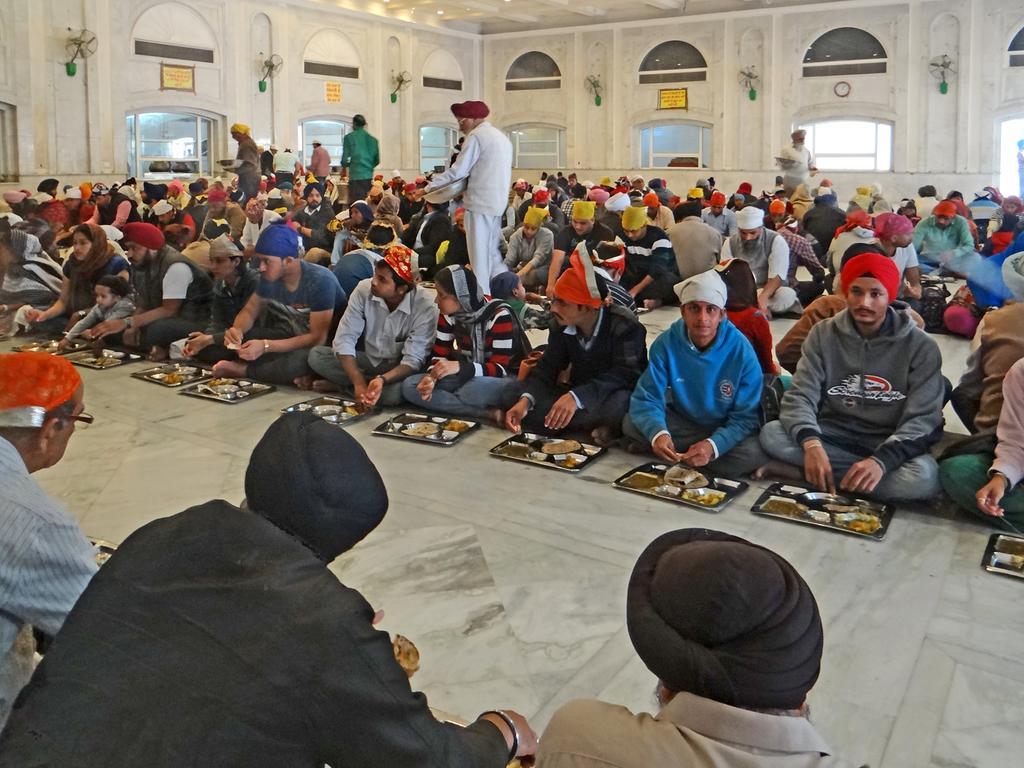Can you describe this image briefly? In this picture we can see some people are sitting, there are plates in front of them, we can see food on these plates, there are some people standing in the middle, in the background we can see some boards, fans and glasses. 